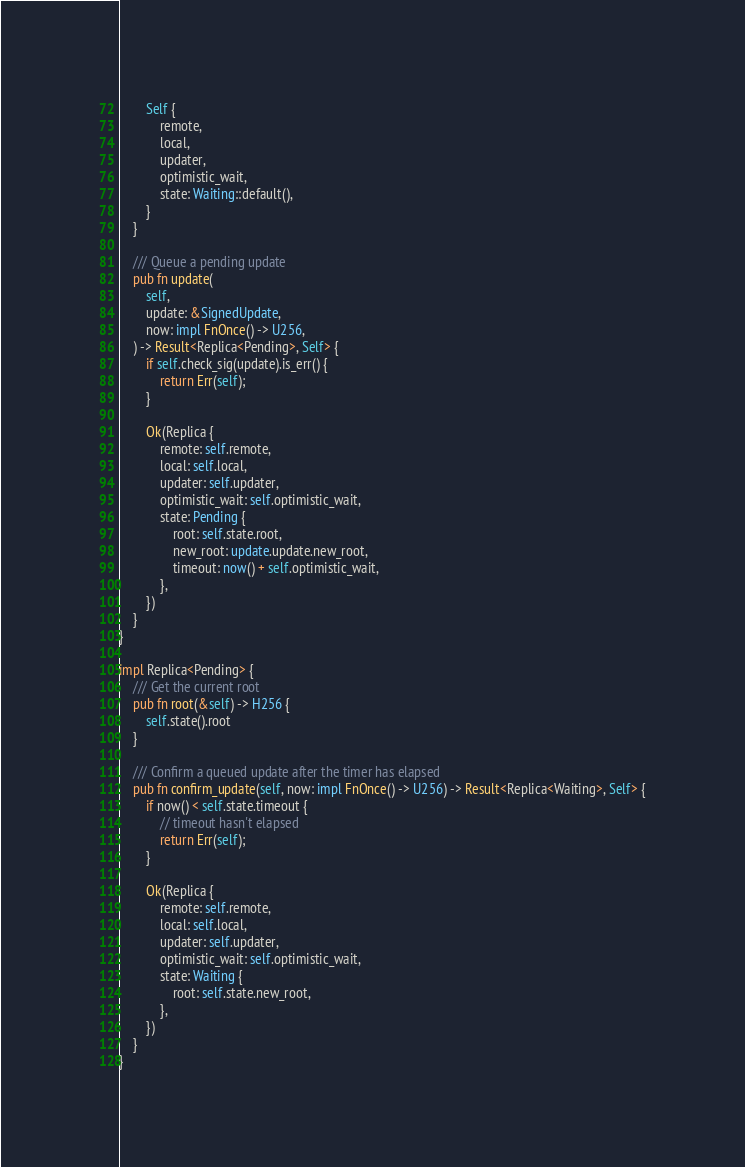<code> <loc_0><loc_0><loc_500><loc_500><_Rust_>        Self {
            remote,
            local,
            updater,
            optimistic_wait,
            state: Waiting::default(),
        }
    }

    /// Queue a pending update
    pub fn update(
        self,
        update: &SignedUpdate,
        now: impl FnOnce() -> U256,
    ) -> Result<Replica<Pending>, Self> {
        if self.check_sig(update).is_err() {
            return Err(self);
        }

        Ok(Replica {
            remote: self.remote,
            local: self.local,
            updater: self.updater,
            optimistic_wait: self.optimistic_wait,
            state: Pending {
                root: self.state.root,
                new_root: update.update.new_root,
                timeout: now() + self.optimistic_wait,
            },
        })
    }
}

impl Replica<Pending> {
    /// Get the current root
    pub fn root(&self) -> H256 {
        self.state().root
    }

    /// Confirm a queued update after the timer has elapsed
    pub fn confirm_update(self, now: impl FnOnce() -> U256) -> Result<Replica<Waiting>, Self> {
        if now() < self.state.timeout {
            // timeout hasn't elapsed
            return Err(self);
        }

        Ok(Replica {
            remote: self.remote,
            local: self.local,
            updater: self.updater,
            optimistic_wait: self.optimistic_wait,
            state: Waiting {
                root: self.state.new_root,
            },
        })
    }
}
</code> 